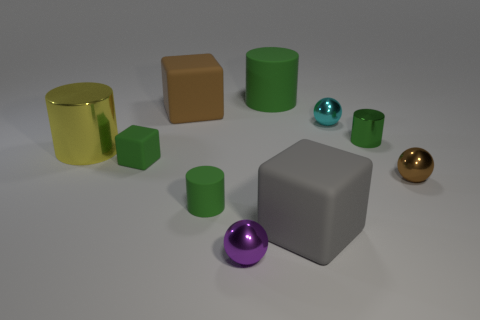How many green cylinders must be subtracted to get 1 green cylinders? 2 Subtract all blue cubes. How many green cylinders are left? 3 Subtract all spheres. How many objects are left? 7 Add 6 big green rubber objects. How many big green rubber objects are left? 7 Add 8 gray blocks. How many gray blocks exist? 9 Subtract 0 green spheres. How many objects are left? 10 Subtract all large metallic things. Subtract all yellow cylinders. How many objects are left? 8 